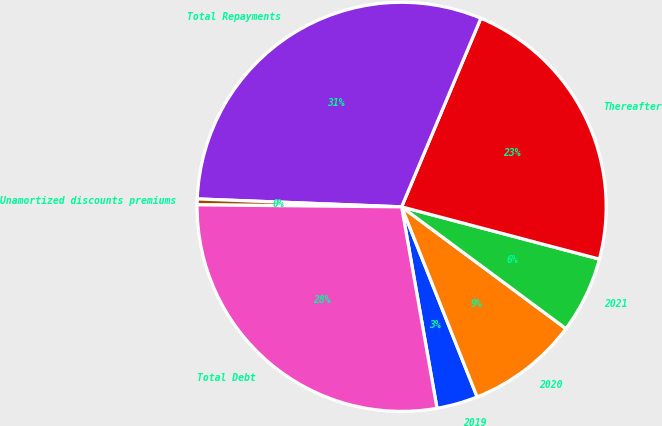Convert chart. <chart><loc_0><loc_0><loc_500><loc_500><pie_chart><fcel>2019<fcel>2020<fcel>2021<fcel>Thereafter<fcel>Total Repayments<fcel>Unamortized discounts premiums<fcel>Total Debt<nl><fcel>3.25%<fcel>8.83%<fcel>6.04%<fcel>22.78%<fcel>30.71%<fcel>0.46%<fcel>27.92%<nl></chart> 